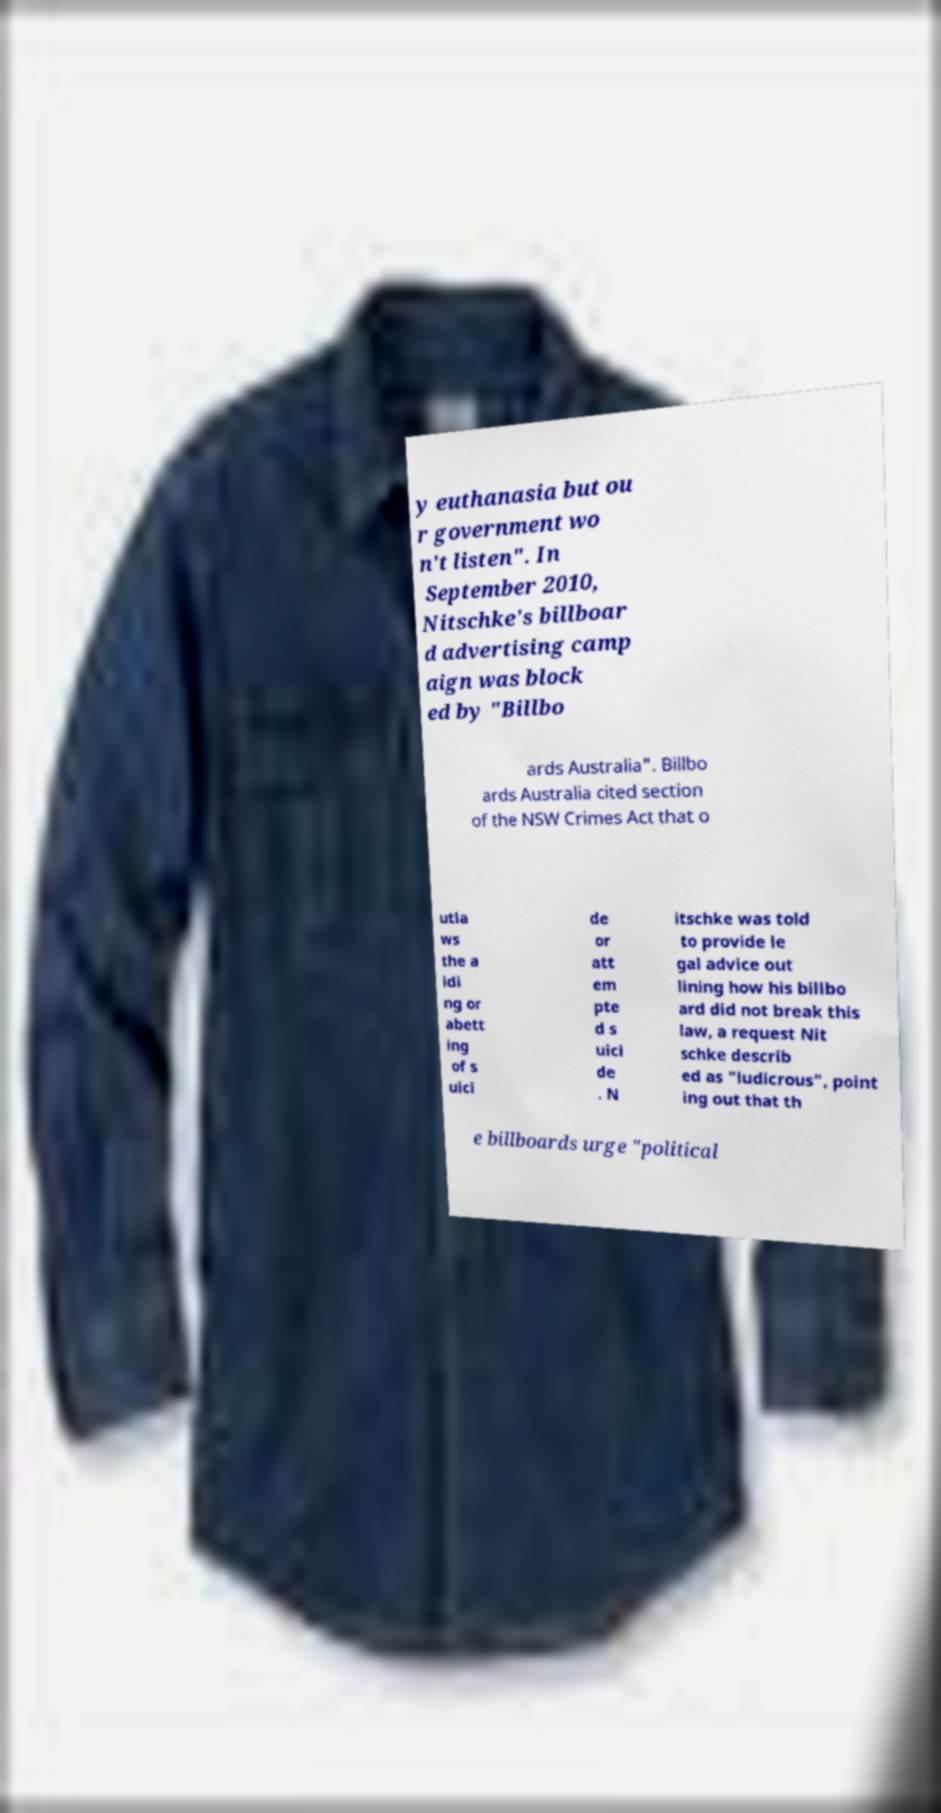What messages or text are displayed in this image? I need them in a readable, typed format. y euthanasia but ou r government wo n't listen". In September 2010, Nitschke's billboar d advertising camp aign was block ed by "Billbo ards Australia". Billbo ards Australia cited section of the NSW Crimes Act that o utla ws the a idi ng or abett ing of s uici de or att em pte d s uici de . N itschke was told to provide le gal advice out lining how his billbo ard did not break this law, a request Nit schke describ ed as "ludicrous", point ing out that th e billboards urge "political 